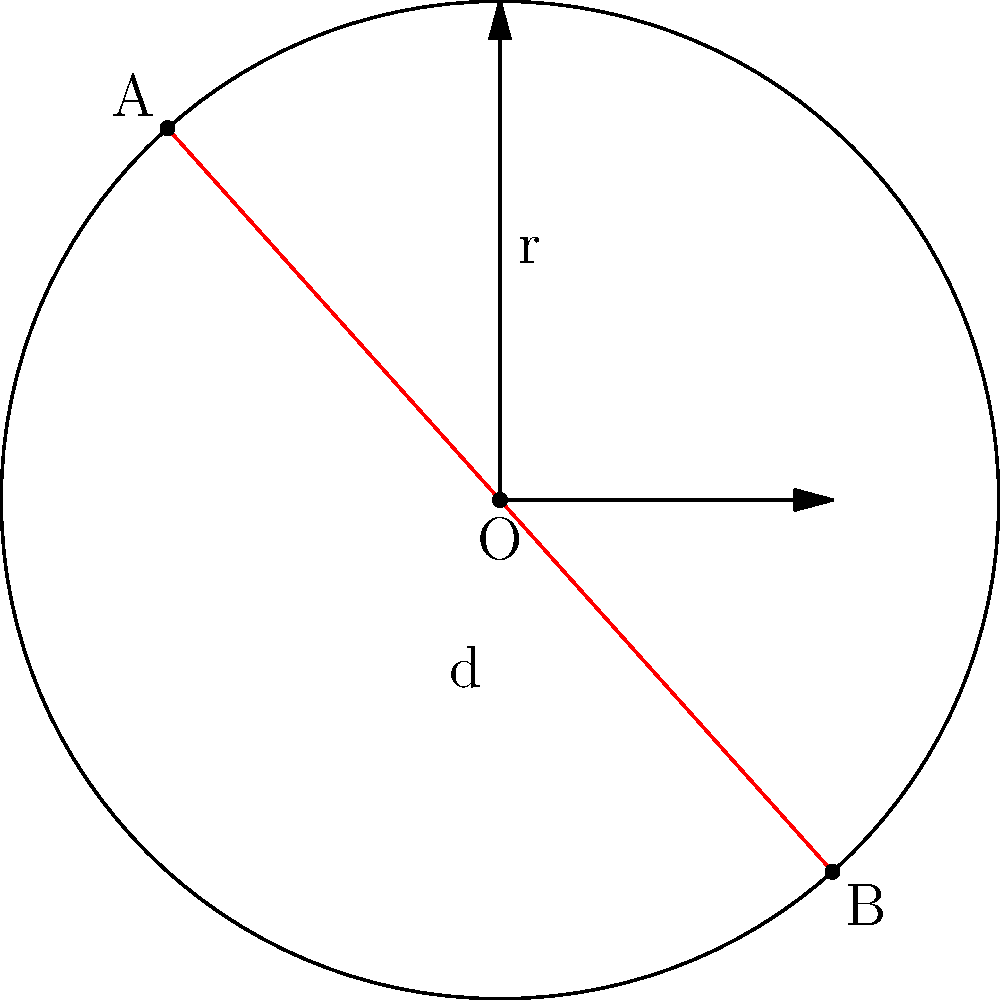In a circular investment portfolio model, the circle represents the total market capitalization, with the radius $r = 3$ billion dollars. A chord AB represents a specific sector's value, and its distance from the center is $d = 2$ billion dollars. Calculate the length of chord AB, which represents the sector's market value, to optimize your investment allocation strategy. Let's approach this step-by-step:

1) In a circle, we can use the Pythagorean theorem to find the length of half the chord. Let's call half the length of the chord $x$.

2) We have a right triangle formed by half the chord, the radius, and the line from the center to the midpoint of the chord.

3) Using the Pythagorean theorem:

   $r^2 = x^2 + d^2$

4) Substituting the known values:

   $3^2 = x^2 + 2^2$

5) Simplify:

   $9 = x^2 + 4$

6) Solve for $x$:

   $x^2 = 5$
   $x = \sqrt{5}$

7) Since $x$ is half the chord length, we need to double it to get the full length:

   $\text{Chord length} = 2x = 2\sqrt{5}$

Therefore, the length of the chord AB, representing the sector's market value, is $2\sqrt{5}$ billion dollars.
Answer: $2\sqrt{5}$ billion dollars 